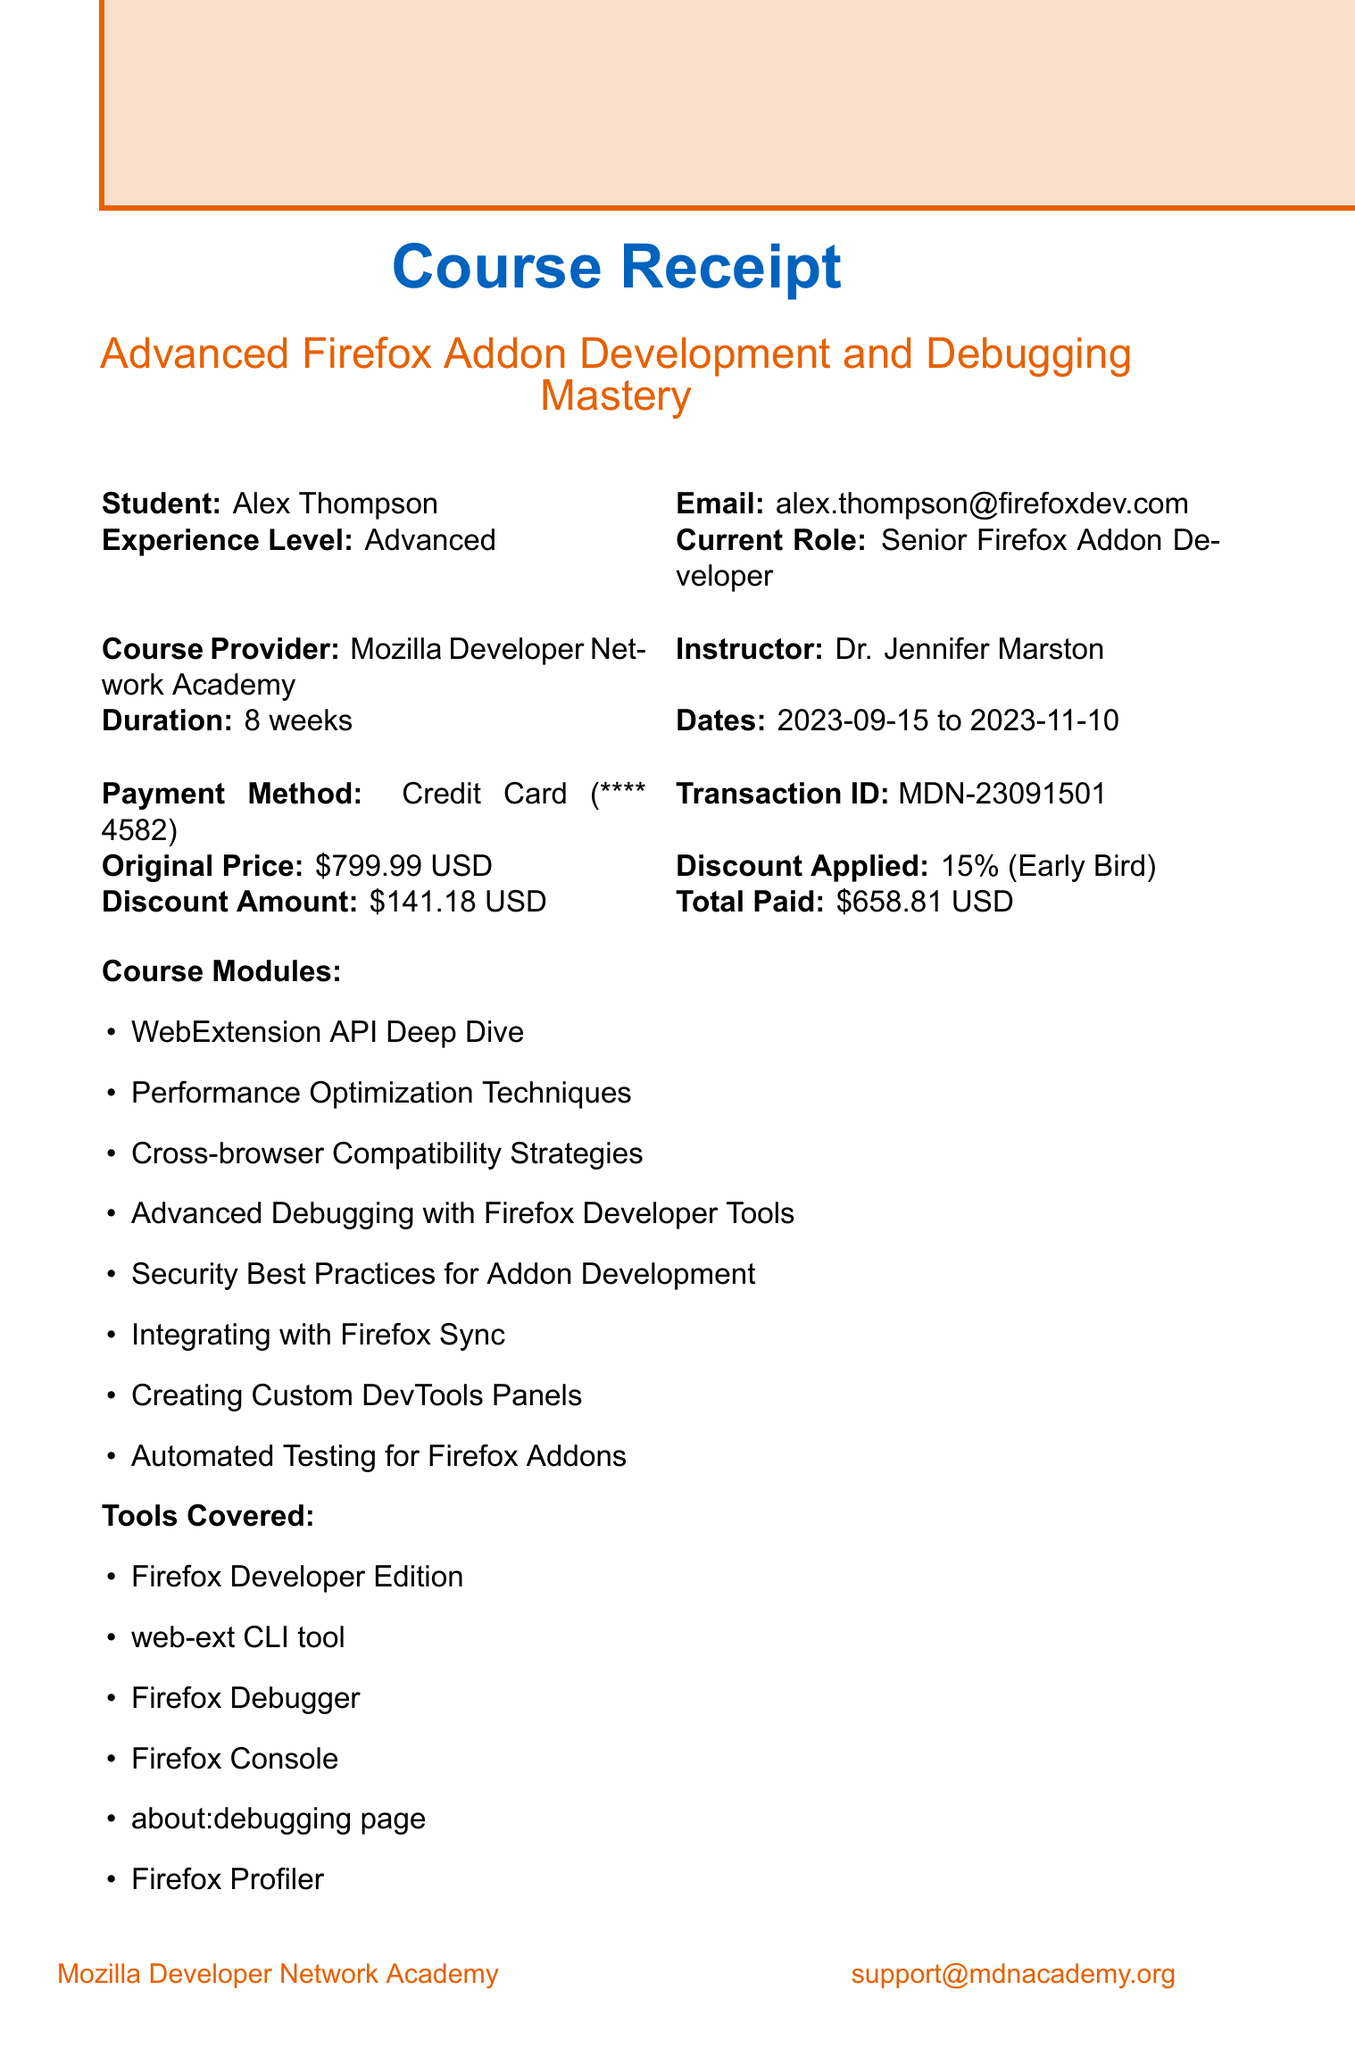What is the name of the course? The course name is provided in the document, which is "Advanced Firefox Addon Development and Debugging Mastery."
Answer: Advanced Firefox Addon Development and Debugging Mastery Who is the instructor of the course? The document states the instructor's name as "Dr. Jennifer Marston."
Answer: Dr. Jennifer Marston What is the total amount paid for the course? The total amount paid is mentioned in the document as "$658.81 USD."
Answer: $658.81 USD What is the discount percentage applied? The discount percentage applied is indicated in the document as "15%."
Answer: 15% How long is the course duration? The duration of the course is specified in the document as "8 weeks."
Answer: 8 weeks What are the system requirements for the course? The document details the system requirements, which include OS, RAM, storage, and software needed to participate in the course.
Answer: Windows 10, macOS 10.15+, or Linux; 8GB minimum RAM; 20GB free space; Latest stable Firefox Developer Edition What is the refund policy? The refund policy in the document specifies that there is a "100% refund available within first 14 days of course start."
Answer: 100% refund available within first 14 days of course start Which tools are covered in the course? The document lists several tools, including the "Firefox Developer Edition" and "Firefox Debugger."
Answer: Firefox Developer Edition, web-ext CLI tool, Firefox Debugger, Firefox Console, about:debugging page, Firefox Profiler, Browser Toolbox, Remote Debugging How many modules are included in the course? The document provides a list of modules, which helps to count them. There are 8 modules mentioned.
Answer: 8 modules 